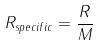<formula> <loc_0><loc_0><loc_500><loc_500>R _ { s p e c i f i c } = \frac { R } { M }</formula> 